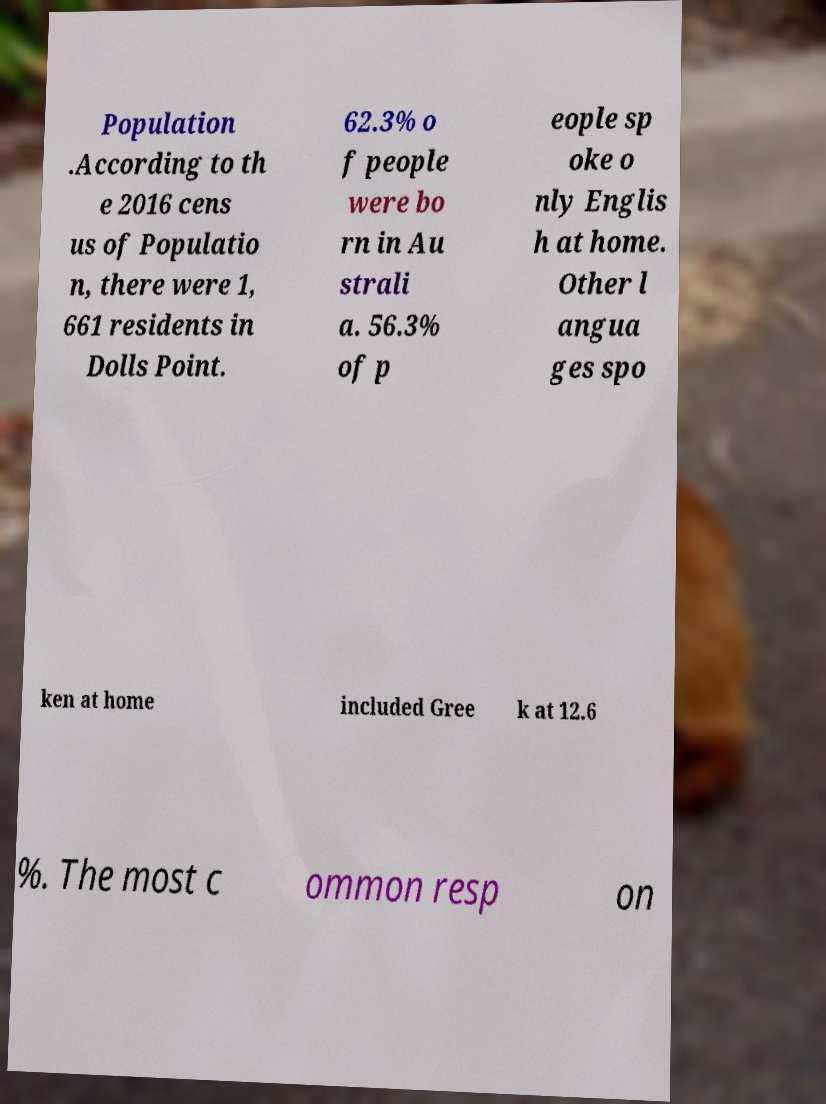There's text embedded in this image that I need extracted. Can you transcribe it verbatim? Population .According to th e 2016 cens us of Populatio n, there were 1, 661 residents in Dolls Point. 62.3% o f people were bo rn in Au strali a. 56.3% of p eople sp oke o nly Englis h at home. Other l angua ges spo ken at home included Gree k at 12.6 %. The most c ommon resp on 